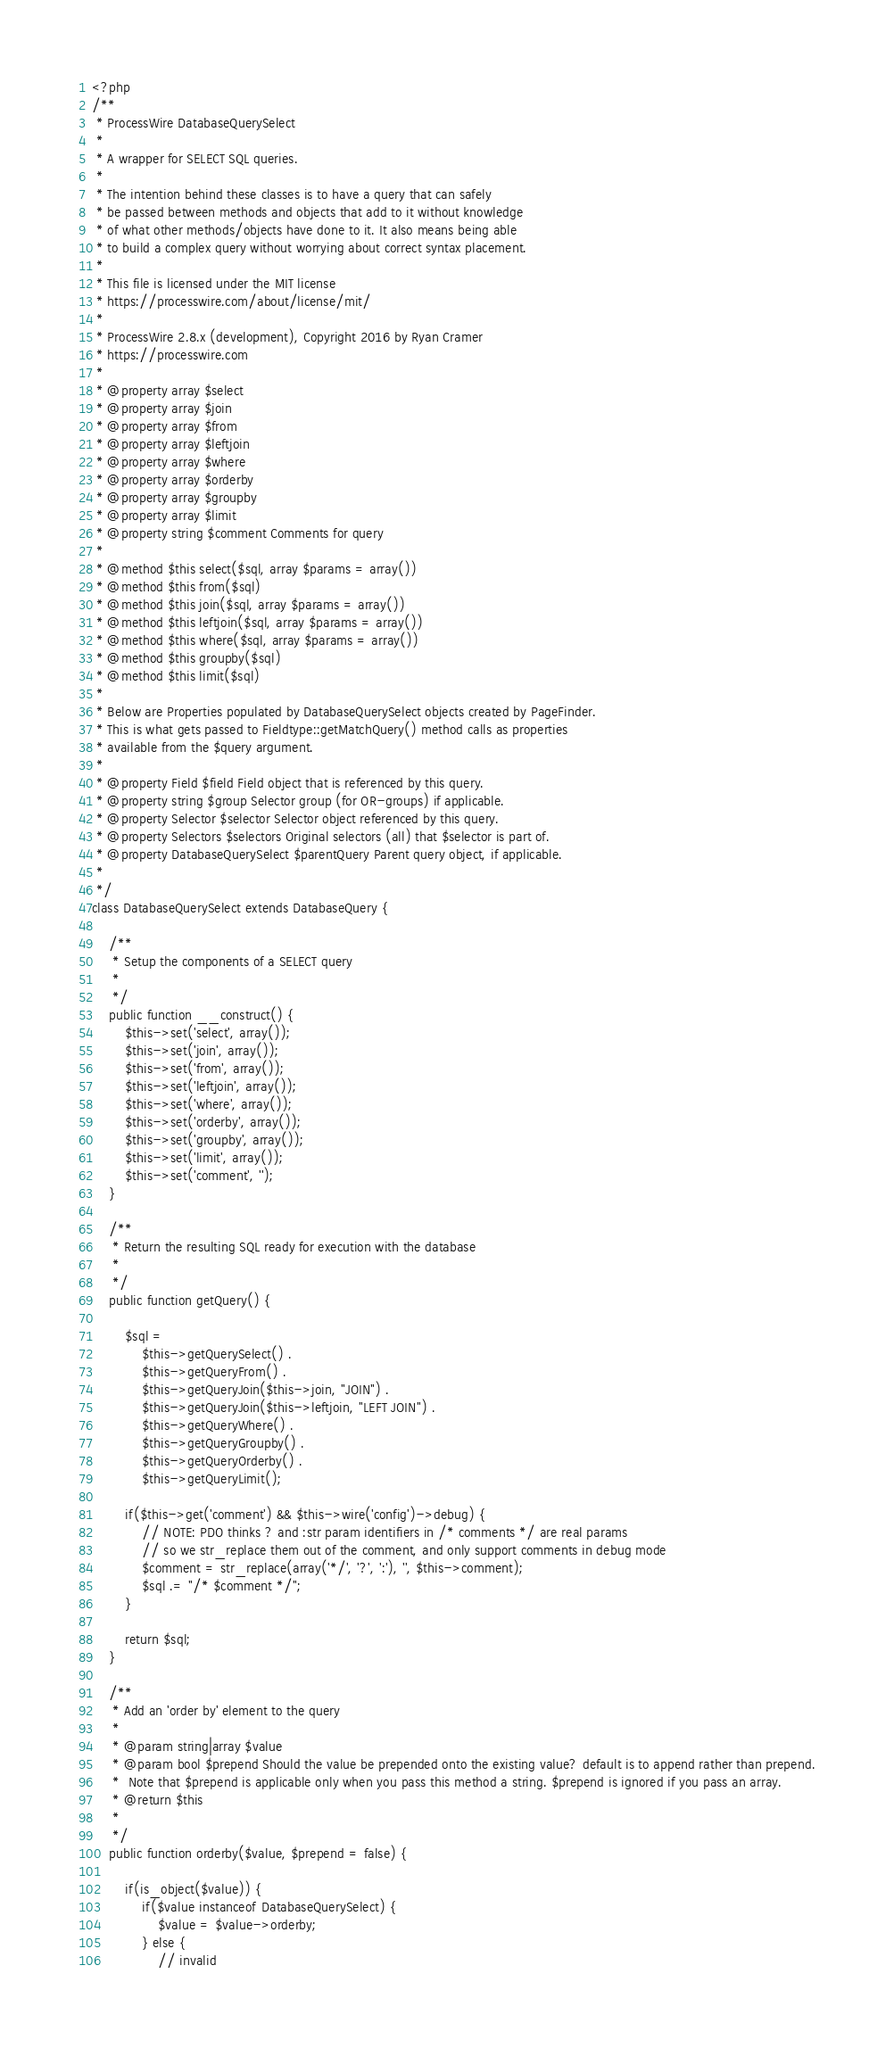<code> <loc_0><loc_0><loc_500><loc_500><_PHP_><?php 
/**
 * ProcessWire DatabaseQuerySelect
 *
 * A wrapper for SELECT SQL queries.
 *
 * The intention behind these classes is to have a query that can safely
 * be passed between methods and objects that add to it without knowledge
 * of what other methods/objects have done to it. It also means being able
 * to build a complex query without worrying about correct syntax placement.
 * 
 * This file is licensed under the MIT license
 * https://processwire.com/about/license/mit/
 * 
 * ProcessWire 2.8.x (development), Copyright 2016 by Ryan Cramer
 * https://processwire.com
 * 
 * @property array $select
 * @property array $join
 * @property array $from
 * @property array $leftjoin
 * @property array $where
 * @property array $orderby
 * @property array $groupby
 * @property array $limit
 * @property string $comment Comments for query
 * 
 * @method $this select($sql, array $params = array())
 * @method $this from($sql)
 * @method $this join($sql, array $params = array())
 * @method $this leftjoin($sql, array $params = array())
 * @method $this where($sql, array $params = array())
 * @method $this groupby($sql)
 * @method $this limit($sql)
 *
 * Below are Properties populated by DatabaseQuerySelect objects created by PageFinder.
 * This is what gets passed to Fieldtype::getMatchQuery() method calls as properties
 * available from the $query argument. 
 * 
 * @property Field $field Field object that is referenced by this query.
 * @property string $group Selector group (for OR-groups) if applicable.
 * @property Selector $selector Selector object referenced by this query.
 * @property Selectors $selectors Original selectors (all) that $selector is part of. 
 * @property DatabaseQuerySelect $parentQuery Parent query object, if applicable.
 *
 */
class DatabaseQuerySelect extends DatabaseQuery {

	/**
	 * Setup the components of a SELECT query
	 *
	 */
	public function __construct() {
		$this->set('select', array()); 
		$this->set('join', array()); 
		$this->set('from', array()); 
		$this->set('leftjoin', array()); 
		$this->set('where', array()); 
		$this->set('orderby', array()); 
		$this->set('groupby', array()); 
		$this->set('limit', array()); 
		$this->set('comment', ''); 
	}

	/**
	 * Return the resulting SQL ready for execution with the database
 	 *
	 */
	public function getQuery() {

		$sql = 	
			$this->getQuerySelect() . 
			$this->getQueryFrom() . 
			$this->getQueryJoin($this->join, "JOIN") . 
			$this->getQueryJoin($this->leftjoin, "LEFT JOIN") . 
			$this->getQueryWhere() . 
			$this->getQueryGroupby() . 
			$this->getQueryOrderby() . 
			$this->getQueryLimit(); 

		if($this->get('comment') && $this->wire('config')->debug) {
			// NOTE: PDO thinks ? and :str param identifiers in /* comments */ are real params
			// so we str_replace them out of the comment, and only support comments in debug mode
			$comment = str_replace(array('*/', '?', ':'), '', $this->comment); 
			$sql .= "/* $comment */";
		}

		return $sql; 
	}

	/**
	 * Add an 'order by' element to the query
	 *
	 * @param string|array $value
	 * @param bool $prepend Should the value be prepended onto the existing value? default is to append rather than prepend.
	 * 	Note that $prepend is applicable only when you pass this method a string. $prepend is ignored if you pass an array. 
	 * @return $this
	 *
	 */
	public function orderby($value, $prepend = false) {
	
		if(is_object($value)) {
			if($value instanceof DatabaseQuerySelect) {
				$value = $value->orderby;
			} else {
				// invalid</code> 